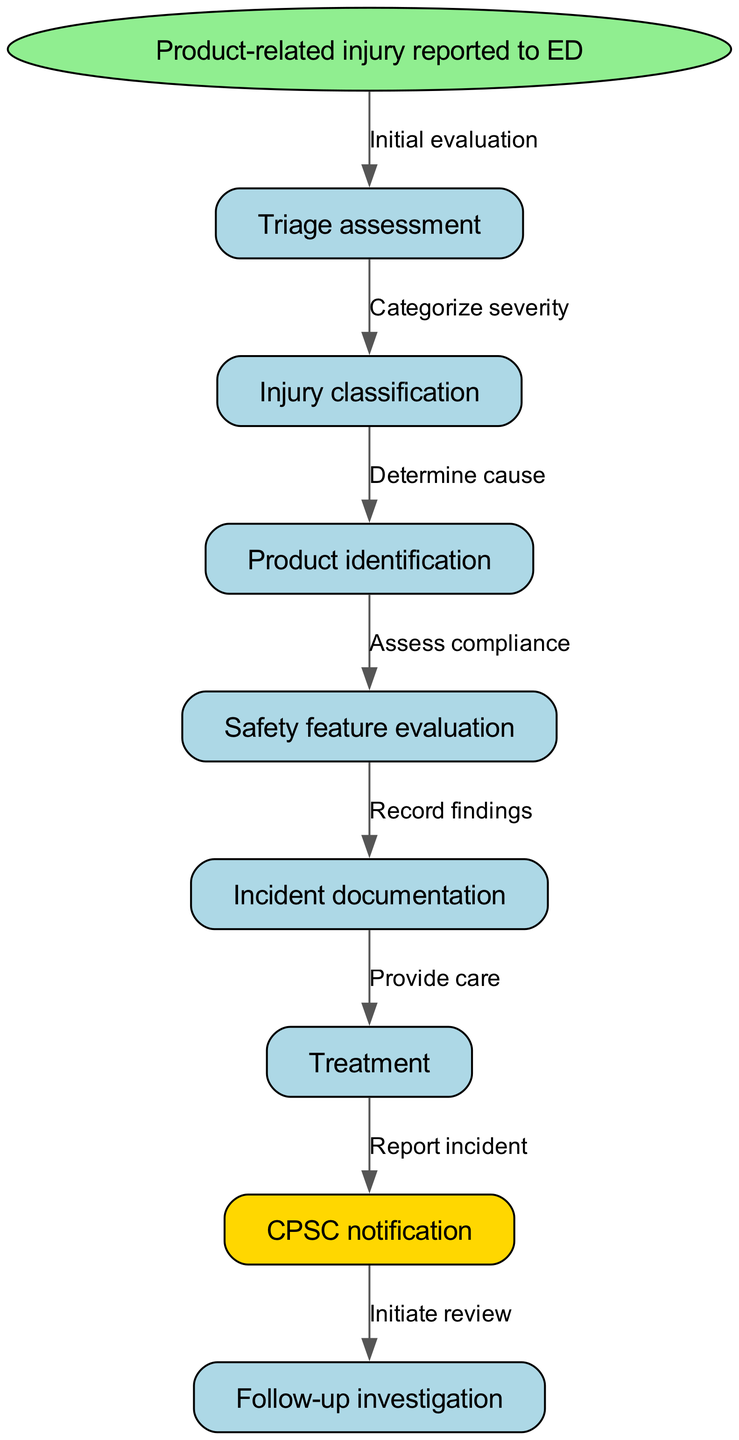What is the first step in the clinical pathway? The first step indicated in the diagram is where a product-related injury is reported to the emergency department (ED). This is the starting point of the pathway.
Answer: Product-related injury reported to ED How many nodes are in the diagram? The diagram includes a total of eight nodes: one starting node and seven subsequent nodes. Counting these nodes gives us the total.
Answer: Eight What is the last step before the follow-up investigation? The diagram shows that the last step before the follow-up investigation is the CPSC notification, which is triggered after the treatment phase.
Answer: CPSC notification Which node follows the injury classification step? According to the diagram, the node that directly follows the injury classification step is the product identification step, indicating the need to determine the cause of the injury.
Answer: Product identification What label is associated with the edge from the safety feature evaluation to incident documentation? The edge connecting these two nodes is labeled "Record findings", which indicates the action taken after evaluating safety features.
Answer: Record findings Which two nodes are connected directly by an edge labeled "Provide care"? The edge labeled "Provide care" connects the incident documentation node to the treatment node, indicating the transition from documenting the incident to treating the injury.
Answer: Incident documentation and Treatment How many edges are there in the diagram? To determine the number of edges, we count the connections shown: there are a total of eight edges linking the various steps in the pathway.
Answer: Eight What happens after treatment is provided according to the clinical pathway? The pathway indicates that after treatment, there is a notification to the CPSC, which is essential for reporting the incident that occurred.
Answer: CPSC notification 